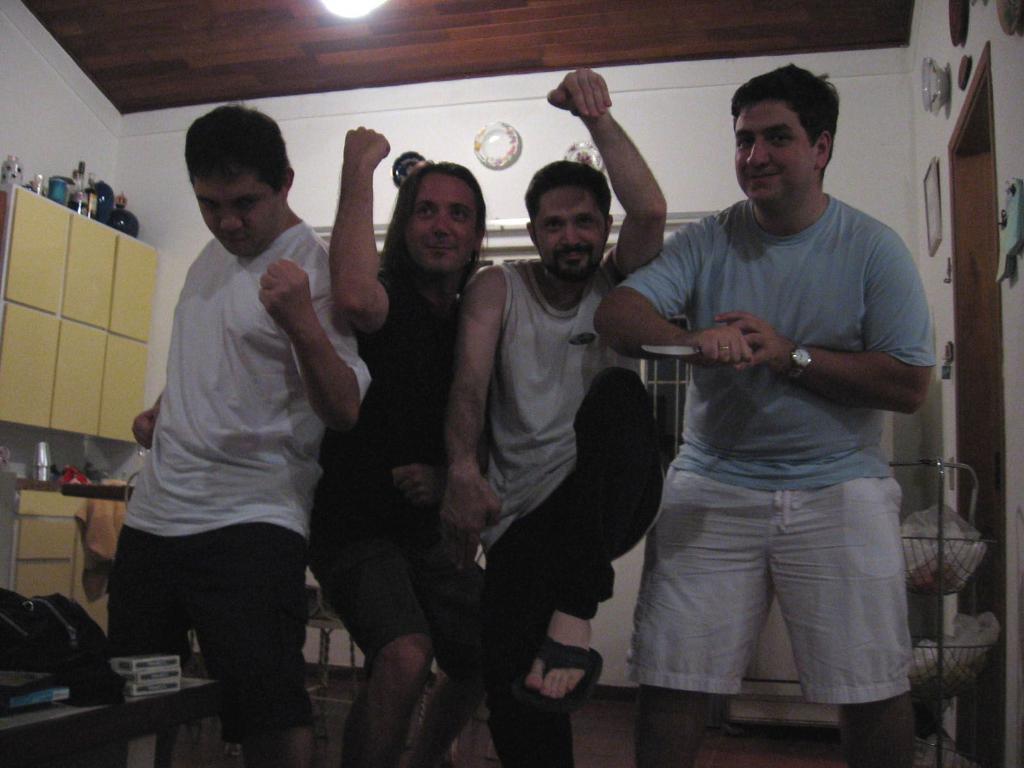Can you describe this image briefly? In this image I can see there are four people, the person at the right side is holding a knife and there are few objects placed on the left side table. There is a shelf in the background at left side and there are few objects placed on the shelf. There are few photo frames placed on the wall in the background. 